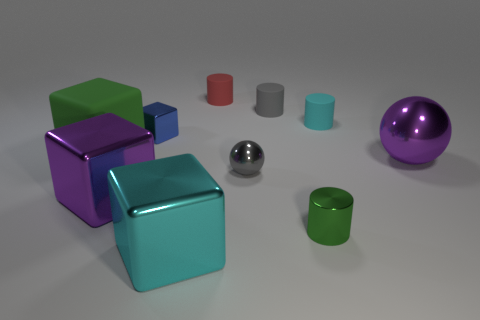Is the number of small blue cubes less than the number of yellow rubber cubes?
Make the answer very short. No. There is a purple metal object that is to the right of the large purple object in front of the small gray ball; are there any cyan objects to the right of it?
Your answer should be very brief. No. There is a big purple thing left of the cyan metallic object; is it the same shape as the cyan rubber object?
Your answer should be compact. No. Is the number of metal blocks that are behind the red object greater than the number of big red objects?
Make the answer very short. No. Is the color of the small metal thing behind the green matte thing the same as the large ball?
Your answer should be compact. No. Is there any other thing that has the same color as the large metallic sphere?
Give a very brief answer. Yes. What is the color of the cylinder that is in front of the large purple object that is on the right side of the tiny shiny thing that is to the left of the red rubber object?
Ensure brevity in your answer.  Green. Do the cyan cylinder and the green rubber cube have the same size?
Provide a succinct answer. No. What number of metallic blocks have the same size as the red rubber object?
Offer a terse response. 1. The metal thing that is the same color as the matte block is what shape?
Offer a very short reply. Cylinder. 